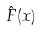<formula> <loc_0><loc_0><loc_500><loc_500>\hat { F } ( x )</formula> 